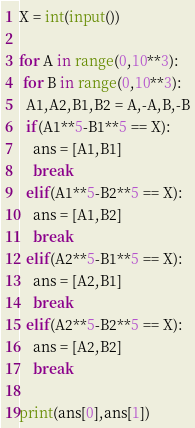<code> <loc_0><loc_0><loc_500><loc_500><_Python_>X = int(input())

for A in range(0,10**3):
 for B in range(0,10**3):
  A1,A2,B1,B2 = A,-A,B,-B
  if(A1**5-B1**5 == X):
    ans = [A1,B1]
    break
  elif(A1**5-B2**5 == X):
    ans = [A1,B2]
    break
  elif(A2**5-B1**5 == X):
    ans = [A2,B1]
    break  
  elif(A2**5-B2**5 == X):
    ans = [A2,B2]
    break    
            
print(ans[0],ans[1])   </code> 